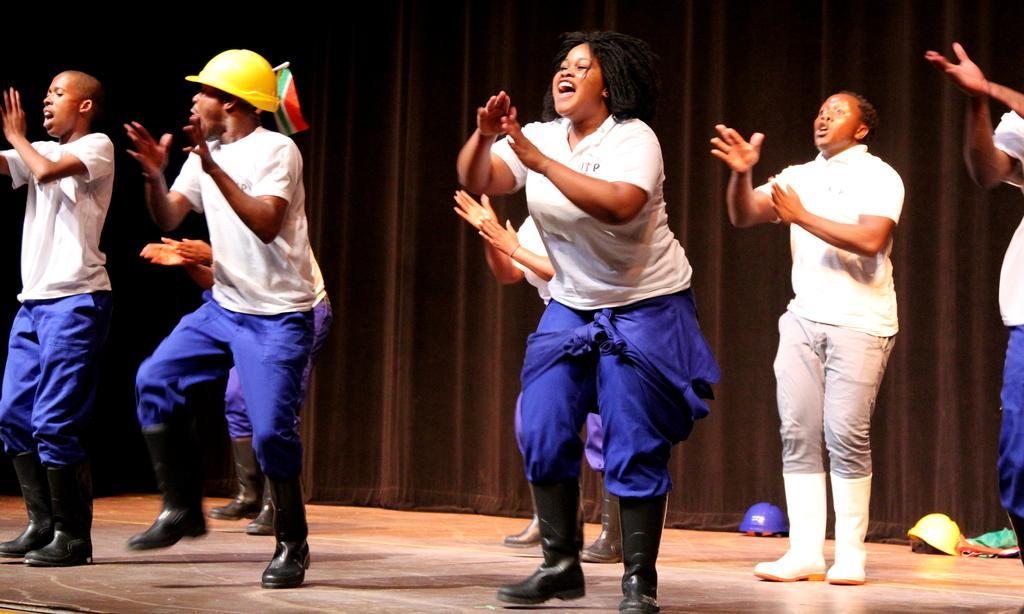Could you give a brief overview of what you see in this image? In this picture we can see some people are dancing, a man on the left side is wearing a helmet, in the background there is a curtain, we can see helmets at the bottom. 